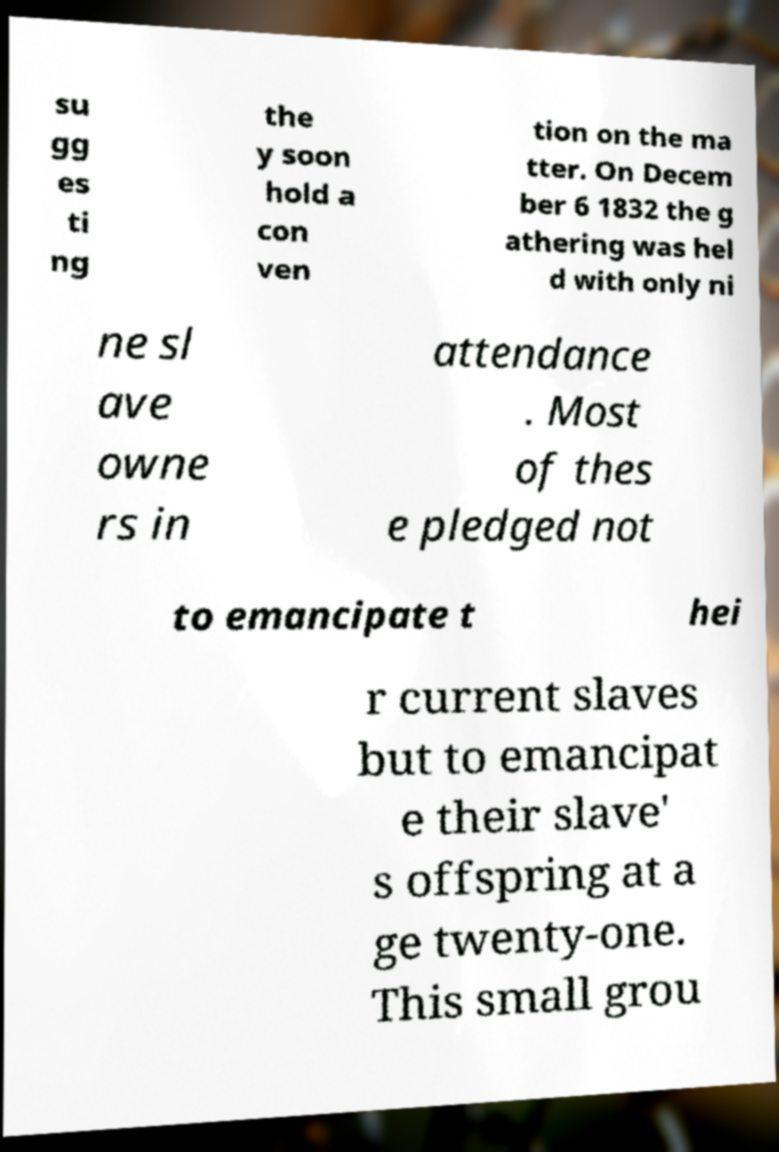Please identify and transcribe the text found in this image. su gg es ti ng the y soon hold a con ven tion on the ma tter. On Decem ber 6 1832 the g athering was hel d with only ni ne sl ave owne rs in attendance . Most of thes e pledged not to emancipate t hei r current slaves but to emancipat e their slave' s offspring at a ge twenty-one. This small grou 